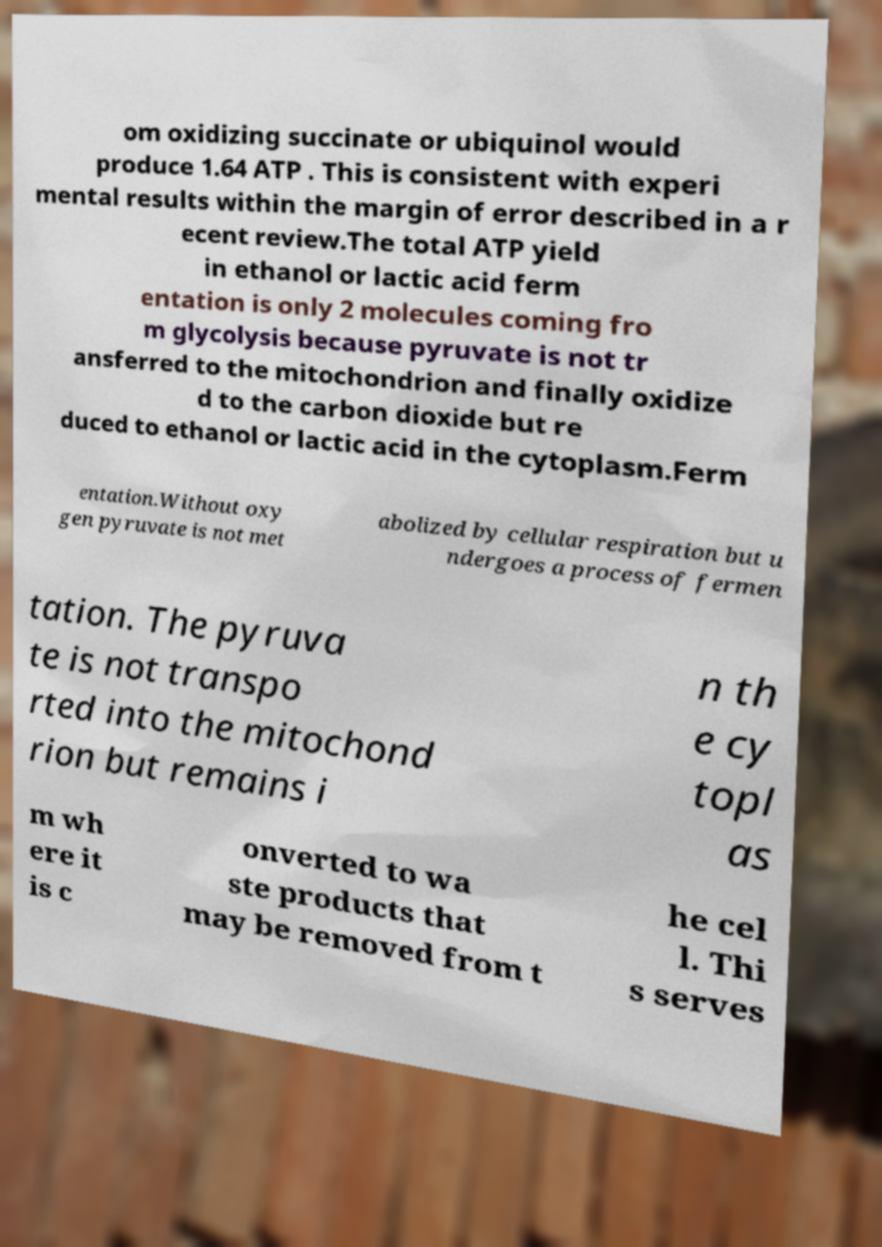Please identify and transcribe the text found in this image. om oxidizing succinate or ubiquinol would produce 1.64 ATP . This is consistent with experi mental results within the margin of error described in a r ecent review.The total ATP yield in ethanol or lactic acid ferm entation is only 2 molecules coming fro m glycolysis because pyruvate is not tr ansferred to the mitochondrion and finally oxidize d to the carbon dioxide but re duced to ethanol or lactic acid in the cytoplasm.Ferm entation.Without oxy gen pyruvate is not met abolized by cellular respiration but u ndergoes a process of fermen tation. The pyruva te is not transpo rted into the mitochond rion but remains i n th e cy topl as m wh ere it is c onverted to wa ste products that may be removed from t he cel l. Thi s serves 